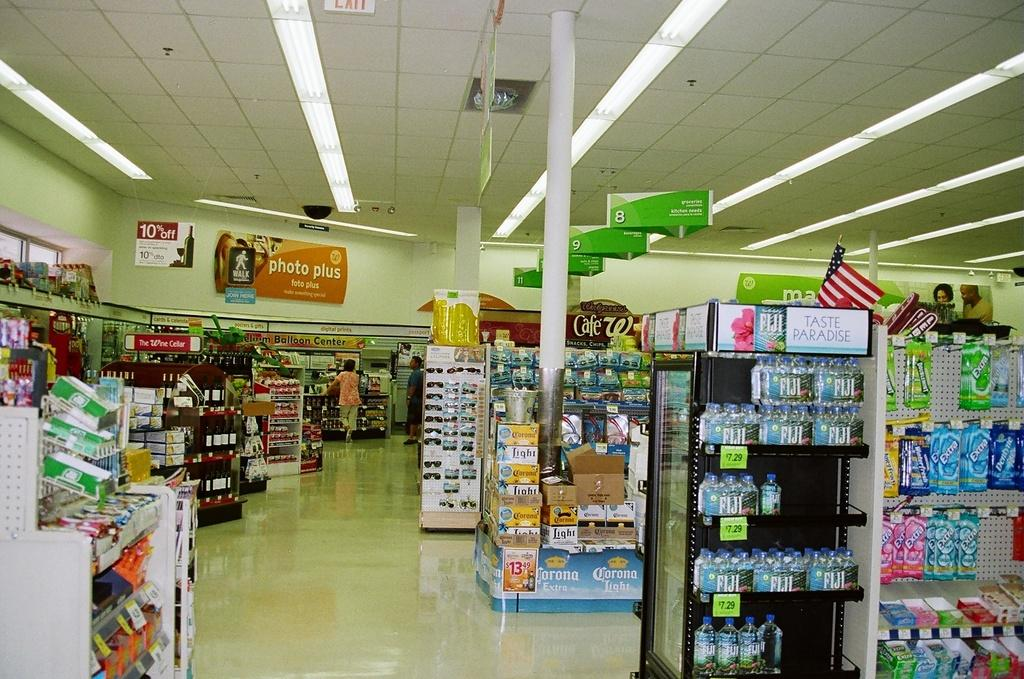<image>
Summarize the visual content of the image. A store with a sign on the wall that says photo plus. 